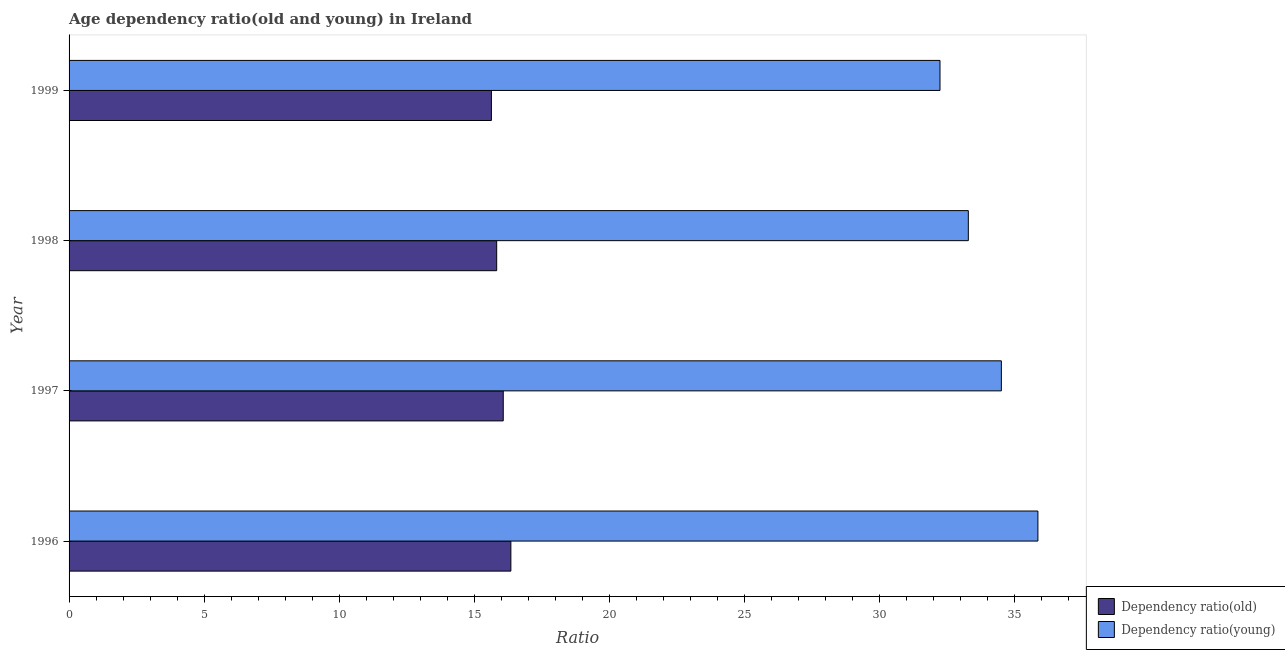Are the number of bars per tick equal to the number of legend labels?
Provide a succinct answer. Yes. What is the label of the 2nd group of bars from the top?
Your answer should be very brief. 1998. In how many cases, is the number of bars for a given year not equal to the number of legend labels?
Offer a terse response. 0. What is the age dependency ratio(old) in 1999?
Your response must be concise. 15.64. Across all years, what is the maximum age dependency ratio(old)?
Ensure brevity in your answer.  16.36. Across all years, what is the minimum age dependency ratio(young)?
Your answer should be very brief. 32.26. In which year was the age dependency ratio(old) maximum?
Your answer should be compact. 1996. What is the total age dependency ratio(young) in the graph?
Your answer should be very brief. 135.97. What is the difference between the age dependency ratio(young) in 1998 and that in 1999?
Ensure brevity in your answer.  1.05. What is the difference between the age dependency ratio(young) in 1998 and the age dependency ratio(old) in 1997?
Offer a very short reply. 17.22. What is the average age dependency ratio(old) per year?
Your response must be concise. 15.98. In the year 1996, what is the difference between the age dependency ratio(young) and age dependency ratio(old)?
Your answer should be compact. 19.52. In how many years, is the age dependency ratio(young) greater than 15 ?
Your response must be concise. 4. Is the age dependency ratio(young) in 1997 less than that in 1999?
Make the answer very short. No. What is the difference between the highest and the second highest age dependency ratio(old)?
Make the answer very short. 0.28. What is the difference between the highest and the lowest age dependency ratio(young)?
Your response must be concise. 3.63. Is the sum of the age dependency ratio(young) in 1998 and 1999 greater than the maximum age dependency ratio(old) across all years?
Provide a succinct answer. Yes. What does the 1st bar from the top in 1996 represents?
Keep it short and to the point. Dependency ratio(young). What does the 1st bar from the bottom in 1998 represents?
Your answer should be compact. Dependency ratio(old). How many bars are there?
Make the answer very short. 8. How many years are there in the graph?
Offer a very short reply. 4. How many legend labels are there?
Your answer should be very brief. 2. How are the legend labels stacked?
Offer a terse response. Vertical. What is the title of the graph?
Your answer should be very brief. Age dependency ratio(old and young) in Ireland. Does "Private credit bureau" appear as one of the legend labels in the graph?
Keep it short and to the point. No. What is the label or title of the X-axis?
Your answer should be compact. Ratio. What is the Ratio in Dependency ratio(old) in 1996?
Ensure brevity in your answer.  16.36. What is the Ratio in Dependency ratio(young) in 1996?
Your answer should be very brief. 35.88. What is the Ratio of Dependency ratio(old) in 1997?
Offer a very short reply. 16.08. What is the Ratio in Dependency ratio(young) in 1997?
Provide a short and direct response. 34.53. What is the Ratio of Dependency ratio(old) in 1998?
Ensure brevity in your answer.  15.84. What is the Ratio in Dependency ratio(young) in 1998?
Offer a very short reply. 33.3. What is the Ratio of Dependency ratio(old) in 1999?
Offer a terse response. 15.64. What is the Ratio in Dependency ratio(young) in 1999?
Provide a short and direct response. 32.26. Across all years, what is the maximum Ratio in Dependency ratio(old)?
Make the answer very short. 16.36. Across all years, what is the maximum Ratio in Dependency ratio(young)?
Your answer should be compact. 35.88. Across all years, what is the minimum Ratio in Dependency ratio(old)?
Keep it short and to the point. 15.64. Across all years, what is the minimum Ratio in Dependency ratio(young)?
Provide a succinct answer. 32.26. What is the total Ratio of Dependency ratio(old) in the graph?
Keep it short and to the point. 63.92. What is the total Ratio of Dependency ratio(young) in the graph?
Offer a very short reply. 135.97. What is the difference between the Ratio in Dependency ratio(old) in 1996 and that in 1997?
Provide a succinct answer. 0.28. What is the difference between the Ratio in Dependency ratio(young) in 1996 and that in 1997?
Ensure brevity in your answer.  1.35. What is the difference between the Ratio of Dependency ratio(old) in 1996 and that in 1998?
Your response must be concise. 0.53. What is the difference between the Ratio in Dependency ratio(young) in 1996 and that in 1998?
Keep it short and to the point. 2.58. What is the difference between the Ratio of Dependency ratio(old) in 1996 and that in 1999?
Ensure brevity in your answer.  0.72. What is the difference between the Ratio in Dependency ratio(young) in 1996 and that in 1999?
Offer a terse response. 3.63. What is the difference between the Ratio in Dependency ratio(old) in 1997 and that in 1998?
Keep it short and to the point. 0.24. What is the difference between the Ratio in Dependency ratio(young) in 1997 and that in 1998?
Offer a very short reply. 1.22. What is the difference between the Ratio of Dependency ratio(old) in 1997 and that in 1999?
Give a very brief answer. 0.44. What is the difference between the Ratio of Dependency ratio(young) in 1997 and that in 1999?
Your answer should be compact. 2.27. What is the difference between the Ratio in Dependency ratio(old) in 1998 and that in 1999?
Provide a succinct answer. 0.2. What is the difference between the Ratio in Dependency ratio(young) in 1998 and that in 1999?
Your answer should be compact. 1.05. What is the difference between the Ratio in Dependency ratio(old) in 1996 and the Ratio in Dependency ratio(young) in 1997?
Provide a succinct answer. -18.17. What is the difference between the Ratio of Dependency ratio(old) in 1996 and the Ratio of Dependency ratio(young) in 1998?
Make the answer very short. -16.94. What is the difference between the Ratio in Dependency ratio(old) in 1996 and the Ratio in Dependency ratio(young) in 1999?
Make the answer very short. -15.89. What is the difference between the Ratio of Dependency ratio(old) in 1997 and the Ratio of Dependency ratio(young) in 1998?
Make the answer very short. -17.22. What is the difference between the Ratio in Dependency ratio(old) in 1997 and the Ratio in Dependency ratio(young) in 1999?
Offer a very short reply. -16.18. What is the difference between the Ratio in Dependency ratio(old) in 1998 and the Ratio in Dependency ratio(young) in 1999?
Provide a succinct answer. -16.42. What is the average Ratio in Dependency ratio(old) per year?
Your answer should be compact. 15.98. What is the average Ratio in Dependency ratio(young) per year?
Your answer should be compact. 33.99. In the year 1996, what is the difference between the Ratio in Dependency ratio(old) and Ratio in Dependency ratio(young)?
Keep it short and to the point. -19.52. In the year 1997, what is the difference between the Ratio in Dependency ratio(old) and Ratio in Dependency ratio(young)?
Your answer should be compact. -18.45. In the year 1998, what is the difference between the Ratio in Dependency ratio(old) and Ratio in Dependency ratio(young)?
Provide a succinct answer. -17.47. In the year 1999, what is the difference between the Ratio of Dependency ratio(old) and Ratio of Dependency ratio(young)?
Keep it short and to the point. -16.61. What is the ratio of the Ratio in Dependency ratio(old) in 1996 to that in 1997?
Your response must be concise. 1.02. What is the ratio of the Ratio of Dependency ratio(young) in 1996 to that in 1997?
Provide a succinct answer. 1.04. What is the ratio of the Ratio in Dependency ratio(old) in 1996 to that in 1998?
Provide a succinct answer. 1.03. What is the ratio of the Ratio of Dependency ratio(young) in 1996 to that in 1998?
Your response must be concise. 1.08. What is the ratio of the Ratio in Dependency ratio(old) in 1996 to that in 1999?
Provide a succinct answer. 1.05. What is the ratio of the Ratio in Dependency ratio(young) in 1996 to that in 1999?
Offer a very short reply. 1.11. What is the ratio of the Ratio of Dependency ratio(old) in 1997 to that in 1998?
Ensure brevity in your answer.  1.02. What is the ratio of the Ratio of Dependency ratio(young) in 1997 to that in 1998?
Ensure brevity in your answer.  1.04. What is the ratio of the Ratio in Dependency ratio(old) in 1997 to that in 1999?
Make the answer very short. 1.03. What is the ratio of the Ratio of Dependency ratio(young) in 1997 to that in 1999?
Offer a terse response. 1.07. What is the ratio of the Ratio in Dependency ratio(old) in 1998 to that in 1999?
Ensure brevity in your answer.  1.01. What is the ratio of the Ratio of Dependency ratio(young) in 1998 to that in 1999?
Your answer should be compact. 1.03. What is the difference between the highest and the second highest Ratio of Dependency ratio(old)?
Your response must be concise. 0.28. What is the difference between the highest and the second highest Ratio of Dependency ratio(young)?
Ensure brevity in your answer.  1.35. What is the difference between the highest and the lowest Ratio in Dependency ratio(old)?
Keep it short and to the point. 0.72. What is the difference between the highest and the lowest Ratio of Dependency ratio(young)?
Your answer should be compact. 3.63. 